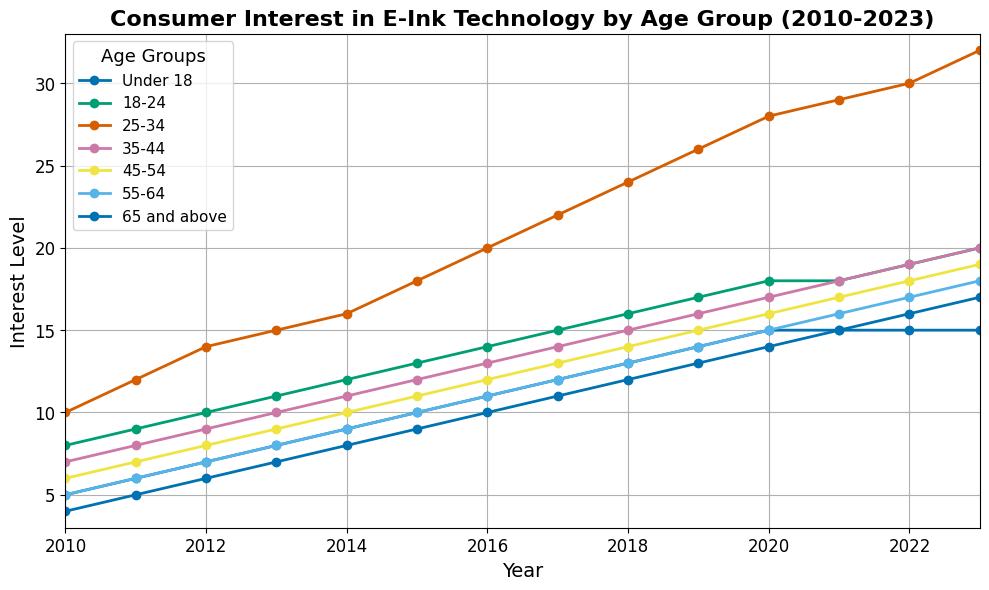What age group showed the highest interest in e-ink technology in 2023? To determine the age group with the highest interest in 2023, we look at the value for each age group in that year. The 25-34 age group has a value of 32, which is the highest among all age groups.
Answer: 25-34 Which age group has the least increase in interest from 2010 to 2023? To find this, calculate the difference in interest between 2023 and 2010 for each age group. The differences are: Under 18 (10), 18-24 (12), 25-34 (22), 35-44 (13), 45-54 (13), 55-64 (13), 65 and above (13). The Under 18 group has the smallest increase of 10.
Answer: Under 18 In which year did the 25-34 age group show the steepest year-over-year increase in interest? To find the steepest increase, calculate the year-over-year changes for 25-34: 2011 (2), 2012 (2), 2013 (1), 2014 (1), 2015 (2), 2016 (2), 2017 (2), 2018 (2), 2019 (2), 2020 (2), 2021 (1), 2022 (1), 2023 (2). The largest jump is from 2010 to 2011 from 10 to 12 and again 2012 to 2013, but since we are looking for "steepest," we go with 2012 to 2013.
Answer: 2013 Is there any age group with no interest change after 2020? To answer this question, look at interest levels for each group from 2020 to 2023. All groups show some change except for the 'Under 18' group, which remains at 15.
Answer: Under 18 Which age group has consistently shown linear growth over the years according to the plot? To determine this, look for age groups whose interest levels increase steadily each year. The '25-34' group shows a consistent linear growth from 2010 to 2023 with no drops.
Answer: 25-34 What's the total increase in interest from 2010 to 2023 for the 35-44 age group? To find this, subtract the 2010 value from the 2023 value for the 35-44 age group: 20 - 7 = 13.
Answer: 13 Which age group had a trend change in 2021 compared to its previous years? Examine the plots for any age group where the trend changes notably around 2021. The interest for the '18-24' age group changes from steady growth to a more significant jump from 18 in 2020 to 19 and 20 in subsequent years.
Answer: 18-24 By what year did the interest level for the '65 and above' age group reach the same level as the '45-54' age group's interest in 2010? We need to find the year when '65 and above' hits the interest level of 6, which is the '45-54' interest in 2010. This happens in 2012.
Answer: 2012 